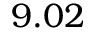Convert formula to latex. <formula><loc_0><loc_0><loc_500><loc_500>9 . 0 2</formula> 